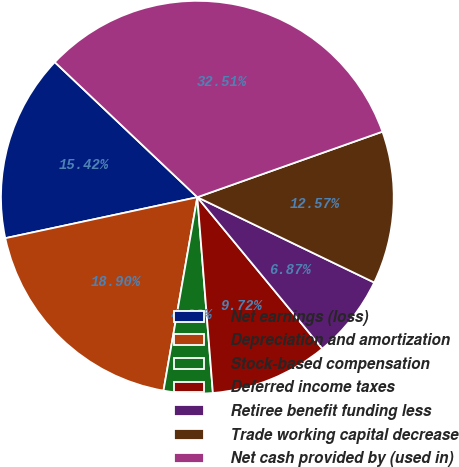<chart> <loc_0><loc_0><loc_500><loc_500><pie_chart><fcel>Net earnings (loss)<fcel>Depreciation and amortization<fcel>Stock-based compensation<fcel>Deferred income taxes<fcel>Retiree benefit funding less<fcel>Trade working capital decrease<fcel>Net cash provided by (used in)<nl><fcel>15.42%<fcel>18.9%<fcel>4.02%<fcel>9.72%<fcel>6.87%<fcel>12.57%<fcel>32.52%<nl></chart> 